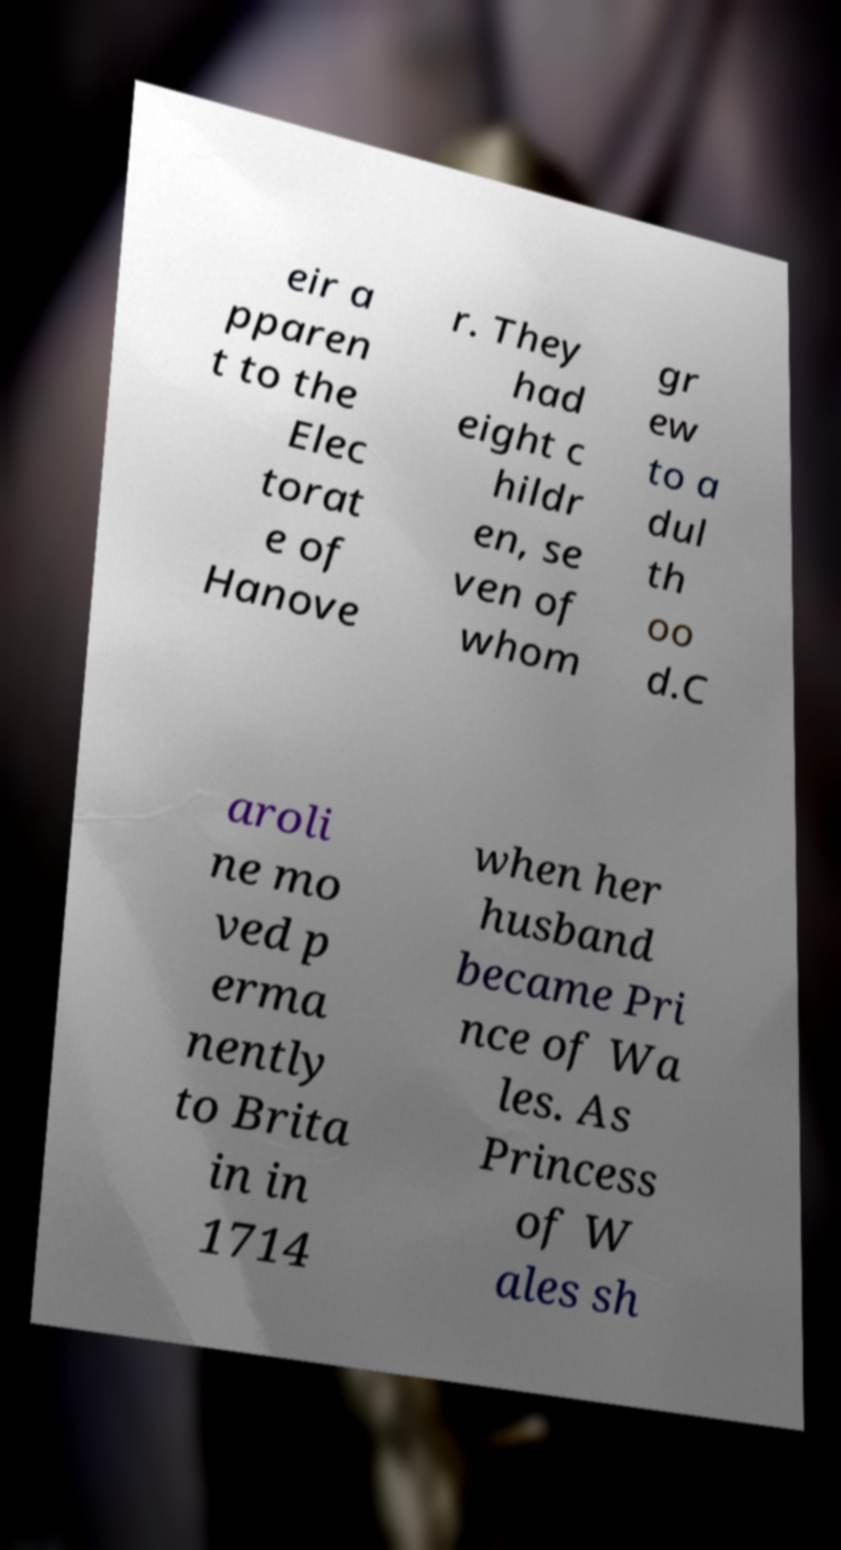Can you accurately transcribe the text from the provided image for me? eir a pparen t to the Elec torat e of Hanove r. They had eight c hildr en, se ven of whom gr ew to a dul th oo d.C aroli ne mo ved p erma nently to Brita in in 1714 when her husband became Pri nce of Wa les. As Princess of W ales sh 